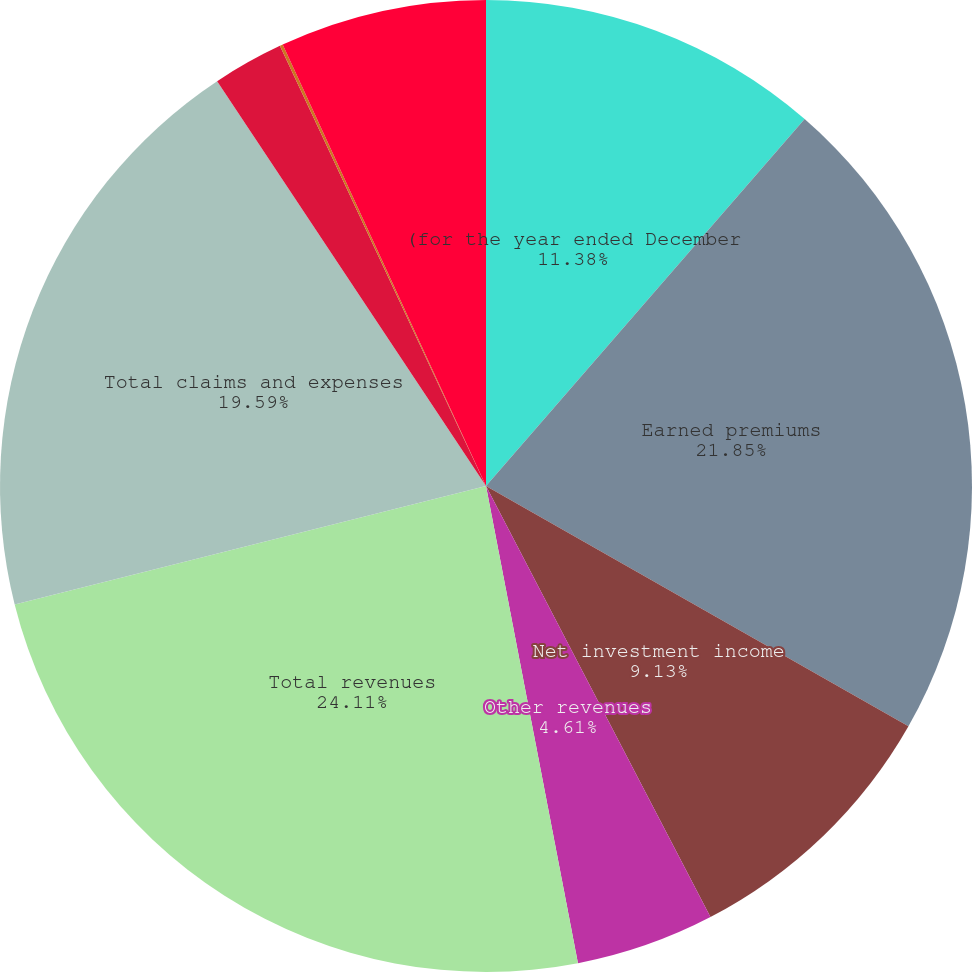Convert chart to OTSL. <chart><loc_0><loc_0><loc_500><loc_500><pie_chart><fcel>(for the year ended December<fcel>Earned premiums<fcel>Net investment income<fcel>Other revenues<fcel>Total revenues<fcel>Total claims and expenses<fcel>Loss and lossadjustment<fcel>Underwriting expense ratio<fcel>GAAP combined ratio<nl><fcel>11.38%<fcel>21.85%<fcel>9.13%<fcel>4.61%<fcel>24.11%<fcel>19.59%<fcel>2.36%<fcel>0.1%<fcel>6.87%<nl></chart> 